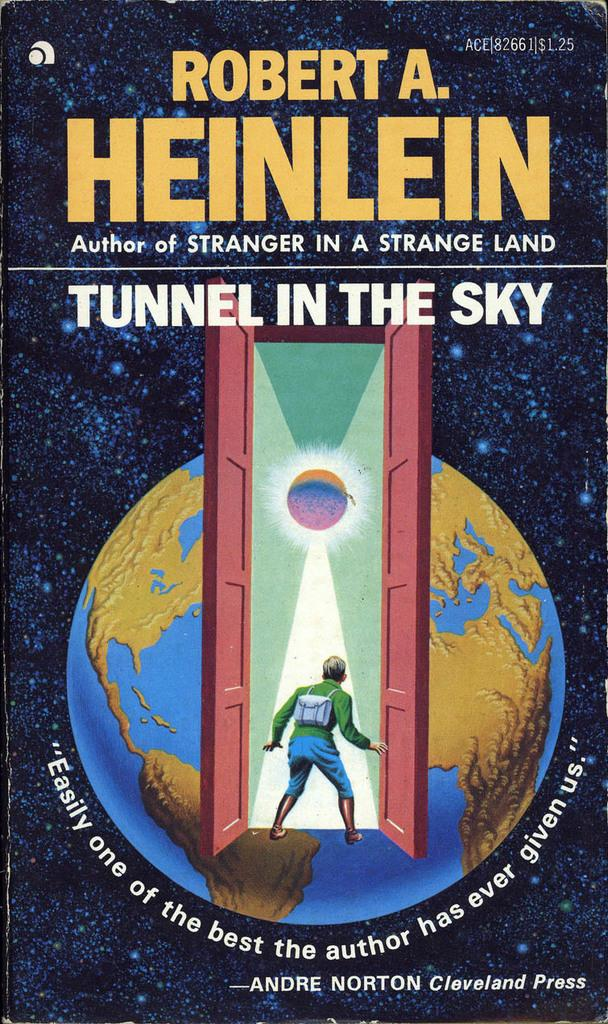<image>
Write a terse but informative summary of the picture. A copy of Robert A. Heinlein's Tunnel in the Sky. 